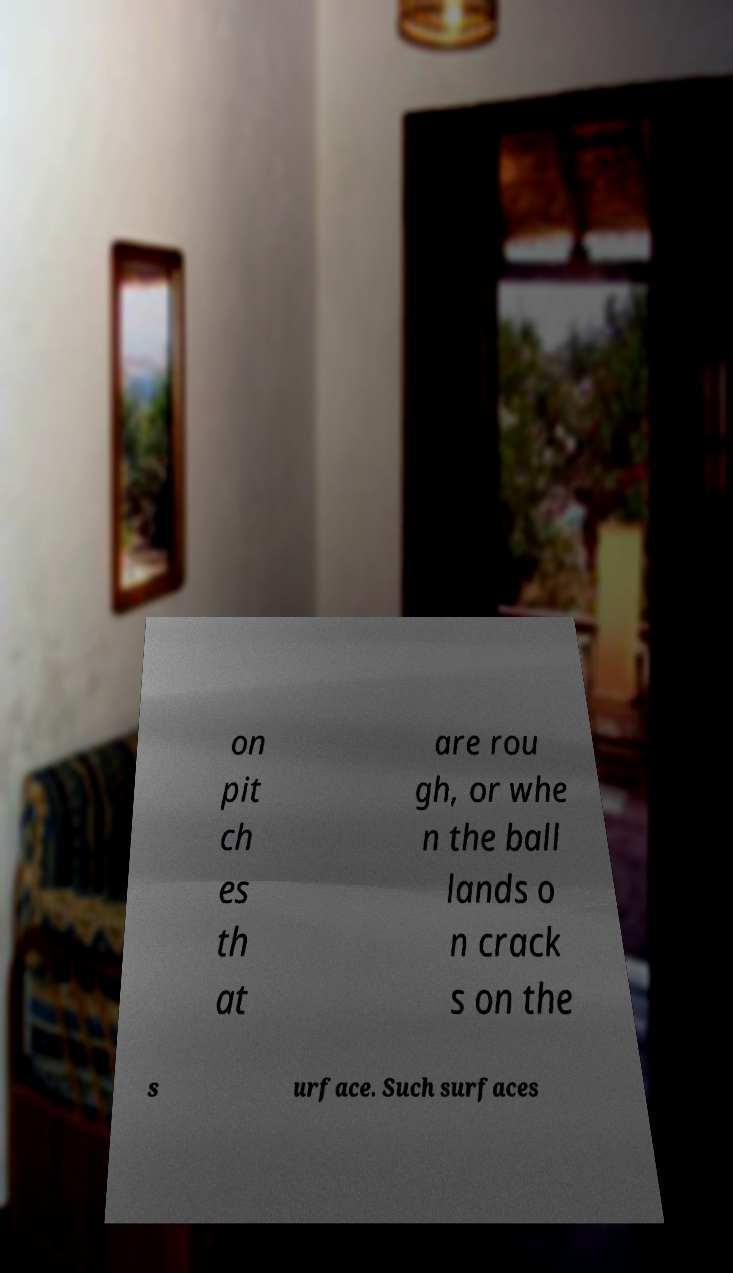For documentation purposes, I need the text within this image transcribed. Could you provide that? on pit ch es th at are rou gh, or whe n the ball lands o n crack s on the s urface. Such surfaces 